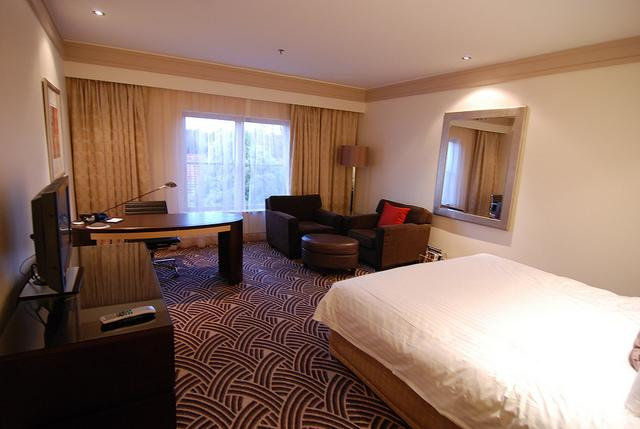The pillow on the couch is the same color as what? Please explain your reasoning. tomato. The pillow is a bright red. 